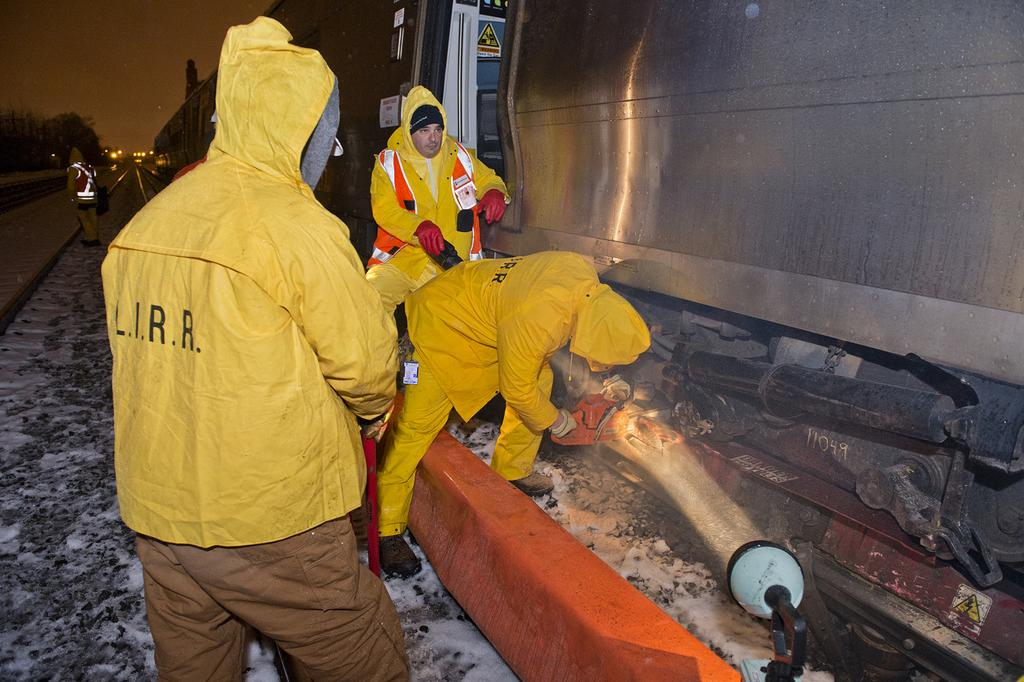How many people are in the image? There are three people in the image. What are the people wearing? The people are wearing jackets. What are the people doing with the object on the ground? The people are doing something with an object on the ground, but the specific action is not clear from the facts provided. What is the condition of the ground in the image? There is snow on the ground in the image. Can you describe the presence of another person in the image? There is another person visible in the background of the image. What type of back pain is the person in the background experiencing? There is no information about any person's back pain in the image, so it cannot be determined. 